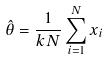Convert formula to latex. <formula><loc_0><loc_0><loc_500><loc_500>\hat { \theta } = \frac { 1 } { k N } \sum _ { i = 1 } ^ { N } x _ { i }</formula> 